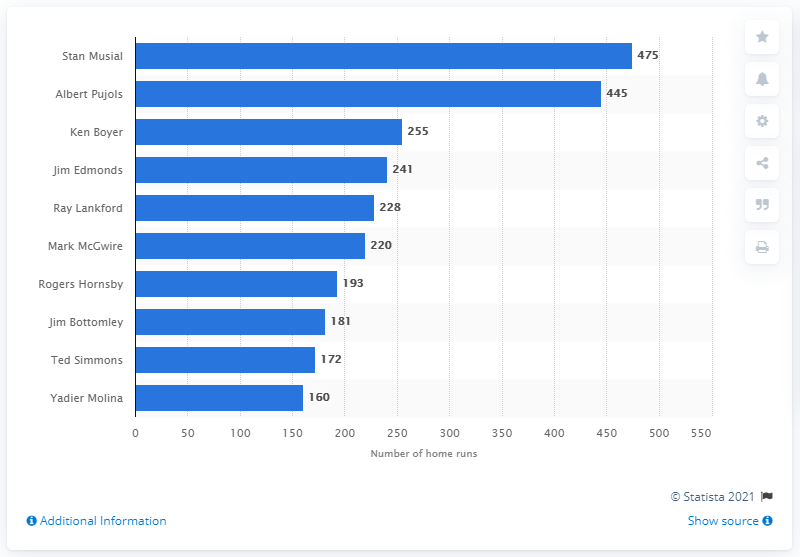Highlight a few significant elements in this photo. The individual who has hit the most home runs in the history of the St. Louis Cardinals franchise is Stan Musial. 